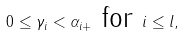Convert formula to latex. <formula><loc_0><loc_0><loc_500><loc_500>0 \leq \gamma _ { i } < \alpha _ { i + } \text { for } i \leq l ,</formula> 